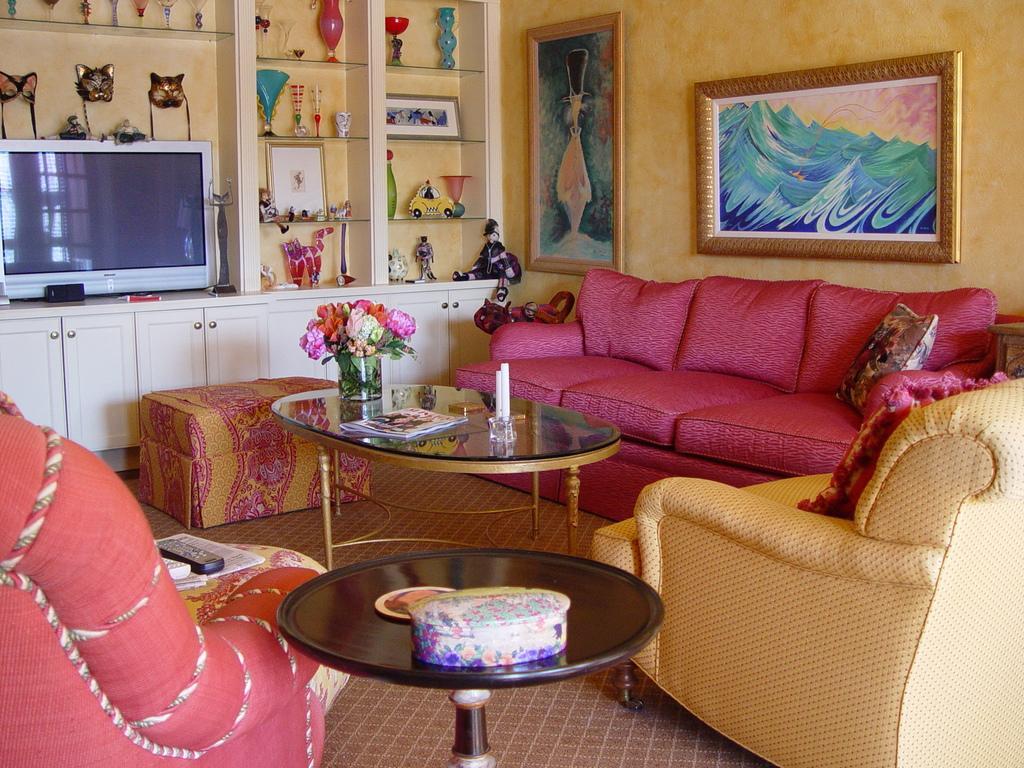Describe this image in one or two sentences. In the picture we can find a room where there are sofas, table, television, decoration items, photo frames, and a wall. On table we can find a flower vase with flowers and a book. On another table we can find a box. 